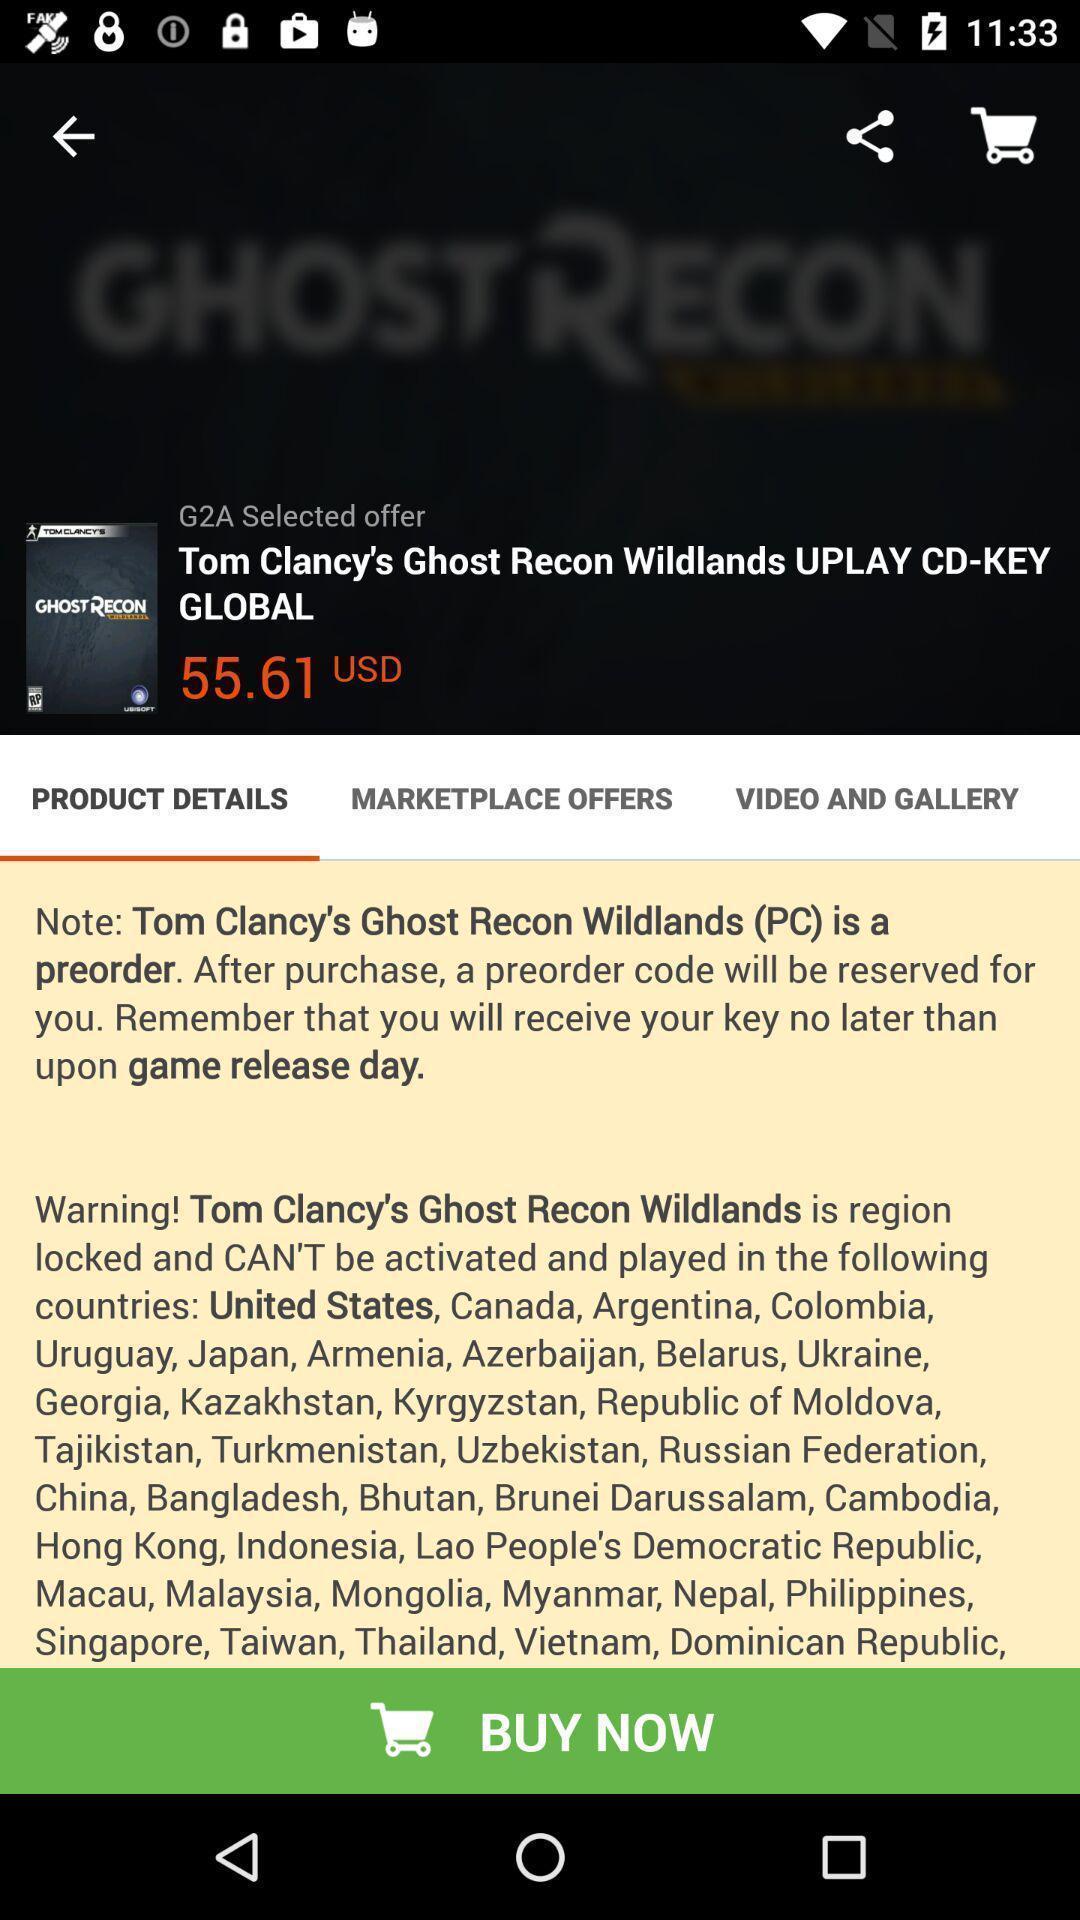Describe the content in this image. Product details info of a shopping app. 